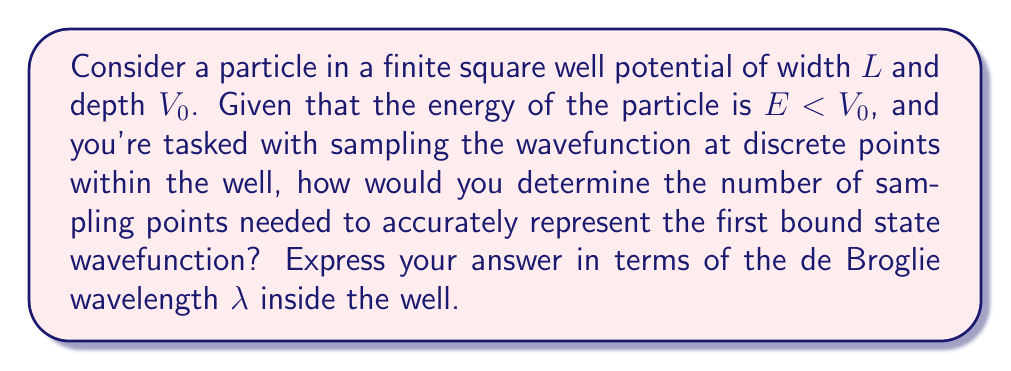Provide a solution to this math problem. To solve this problem, we'll follow these steps:

1) First, recall the Schrödinger equation for a particle in a finite square well:

   $$-\frac{\hbar^2}{2m}\frac{d^2\psi}{dx^2} + V(x)\psi = E\psi$$

   where $V(x) = -V_0$ for $0 < x < L$, and $V(x) = 0$ elsewhere.

2) Inside the well, where $E < V_0$, the solution has the form:

   $$\psi(x) = A \sin(kx) + B \cos(kx)$$

   where $k = \sqrt{\frac{2m(E+V_0)}{\hbar^2}}$

3) The de Broglie wavelength $\lambda$ inside the well is related to $k$ by:

   $$\lambda = \frac{2\pi}{k}$$

4) To accurately represent the wavefunction, we need to sample at a rate that satisfies the Nyquist-Shannon sampling theorem. This theorem states that to reconstruct a continuous function from its samples, the sampling rate must be at least twice the highest frequency component.

5) For the first bound state, the wavefunction has a single half-wavelength within the well. Therefore, the minimum number of sampling points $N$ should be:

   $$N = 2 \cdot \frac{L}{\lambda/2} = \frac{4L}{\lambda}$$

6) This ensures at least 4 samples per wavelength, which is generally considered sufficient for accurate representation of sinusoidal functions.

7) To provide a margin of safety and account for potential higher-frequency components near the well boundaries, we might want to increase this by a factor (e.g., 2), giving us:

   $$N = \frac{8L}{\lambda}$$

This approach aligns with the persona of a statistician specializing in sampling techniques, as it applies sampling theory to a quantum mechanical problem.
Answer: $N = \frac{8L}{\lambda}$ 